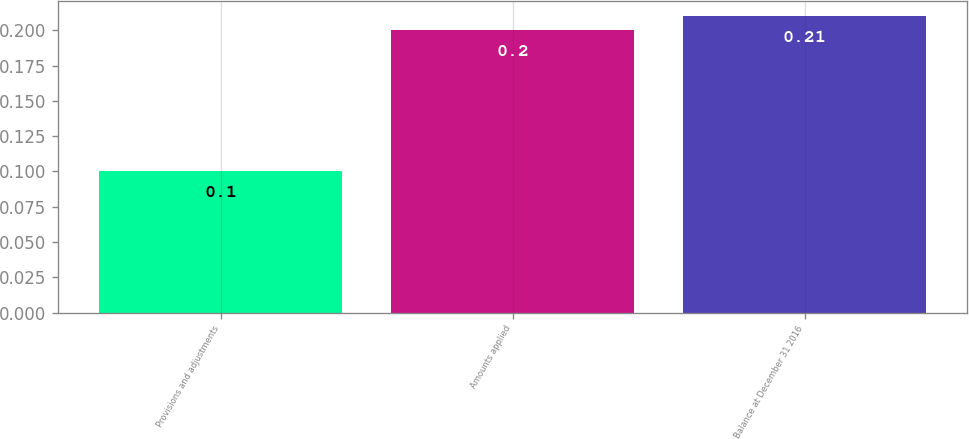<chart> <loc_0><loc_0><loc_500><loc_500><bar_chart><fcel>Provisions and adjustments<fcel>Amounts applied<fcel>Balance at December 31 2016<nl><fcel>0.1<fcel>0.2<fcel>0.21<nl></chart> 